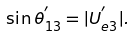Convert formula to latex. <formula><loc_0><loc_0><loc_500><loc_500>\sin \theta _ { 1 3 } ^ { ^ { \prime } } = | U _ { e 3 } ^ { ^ { \prime } } | .</formula> 